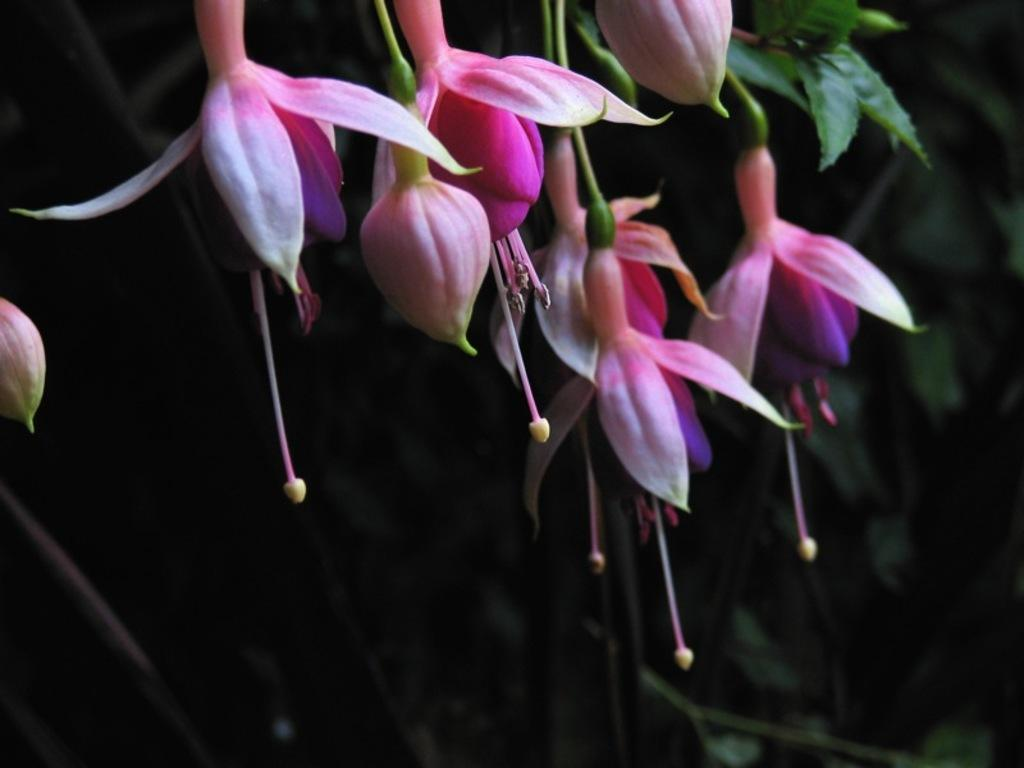What types of plant life can be seen at the top of the image? There are flowers and buds at the top of the image. What else can be seen in the background of the image? There are leaves visible in the background of the image. What economic theory is being discussed in the image? There is no discussion or reference to any economic theory in the image; it primarily features plant life. 